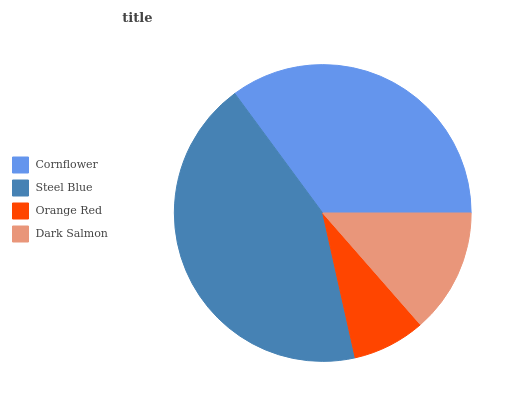Is Orange Red the minimum?
Answer yes or no. Yes. Is Steel Blue the maximum?
Answer yes or no. Yes. Is Steel Blue the minimum?
Answer yes or no. No. Is Orange Red the maximum?
Answer yes or no. No. Is Steel Blue greater than Orange Red?
Answer yes or no. Yes. Is Orange Red less than Steel Blue?
Answer yes or no. Yes. Is Orange Red greater than Steel Blue?
Answer yes or no. No. Is Steel Blue less than Orange Red?
Answer yes or no. No. Is Cornflower the high median?
Answer yes or no. Yes. Is Dark Salmon the low median?
Answer yes or no. Yes. Is Dark Salmon the high median?
Answer yes or no. No. Is Orange Red the low median?
Answer yes or no. No. 